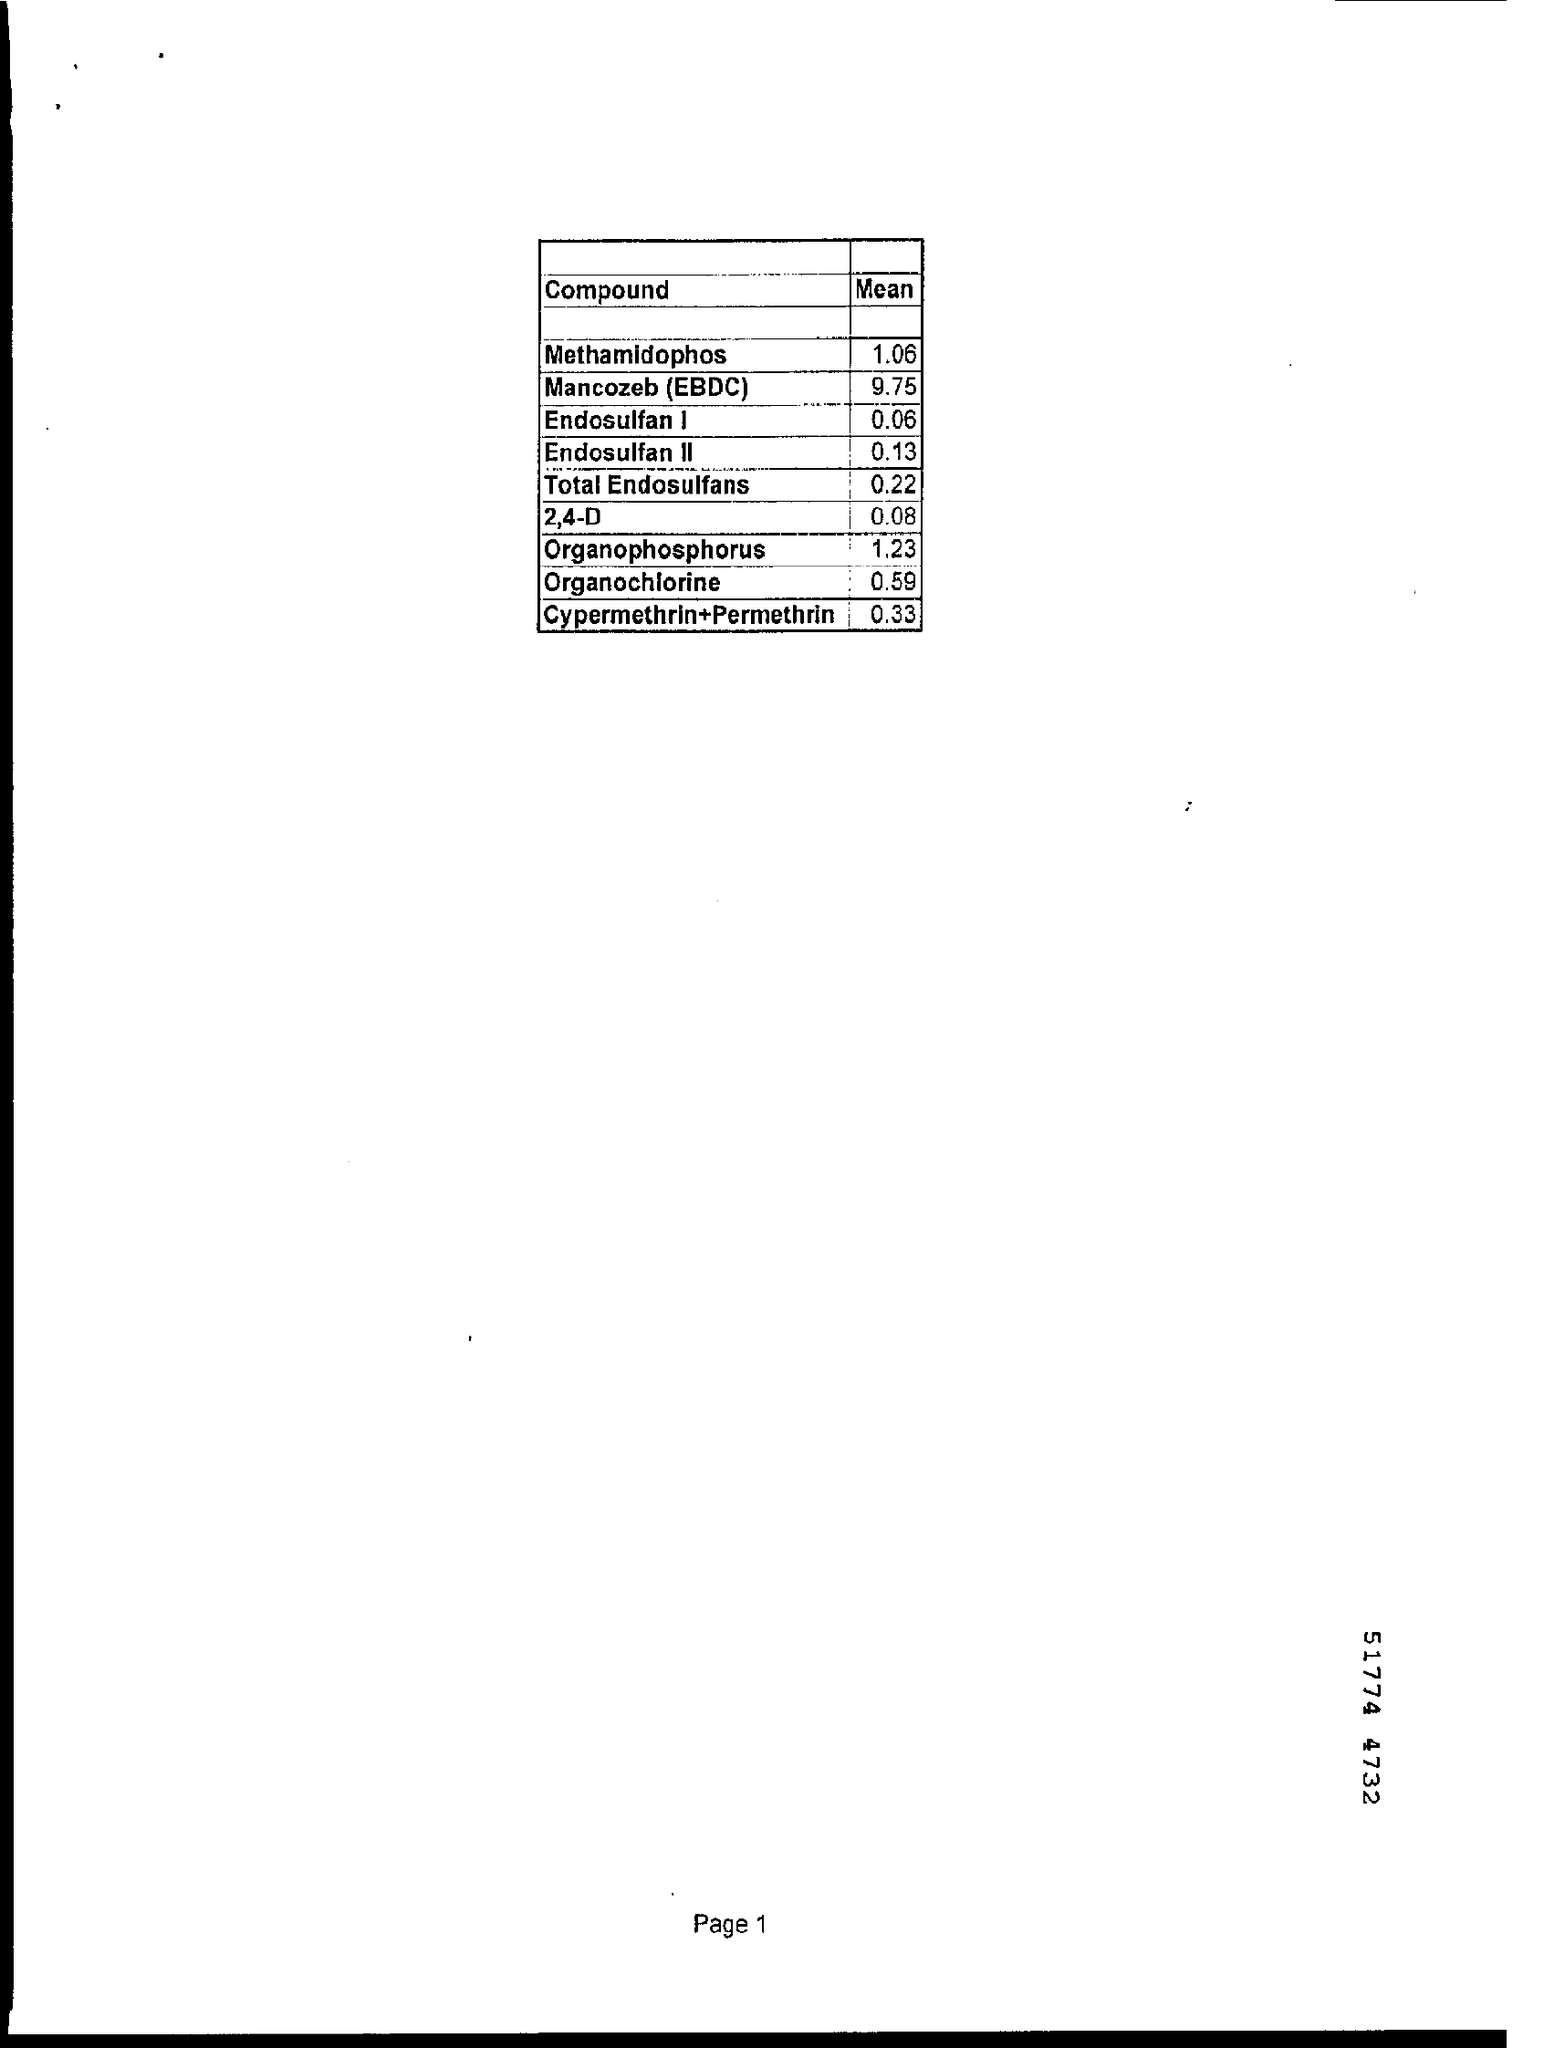Give some essential details in this illustration. The mean of 2,4-D is 0.08. The compound with a mean of 1.23 is an organophosphorus compound. 